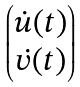<formula> <loc_0><loc_0><loc_500><loc_500>\begin{pmatrix} \dot { u } ( t ) \\ \dot { v } ( t ) \end{pmatrix}</formula> 